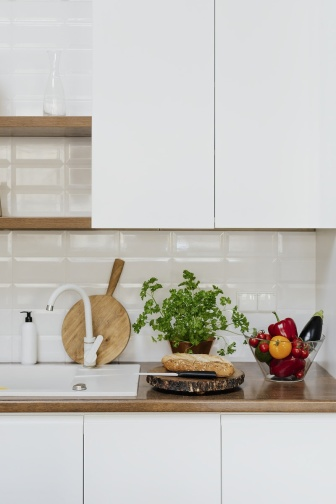What kind of atmosphere does the kitchen portray? The kitchen exudes a serene and organized atmosphere, with its neutral color palette and thoughtfully arranged elements. The combination of white cabinets, light-colored tiles, and wooden accents creates a calming and inviting environment, perfect for cooking and other culinary activities. Can you describe a scenario where this kitchen would be utilized? Imagine a peaceful Sunday morning. The sunlight is streaming through the windows, casting a gentle glow on the kitchen. A home cook prepares breakfast, slicing fruits on the wooden cutting board and using the fresh herbs from the potted plant for seasoning. The aroma of freshly baked bread fills the air, creating a cozy and delightful atmosphere. The kitchen, with its clean and organized setup, perfectly supports the creation of a hearty and delicious meal, contributing to a tranquil and fulfilling start to the day. 